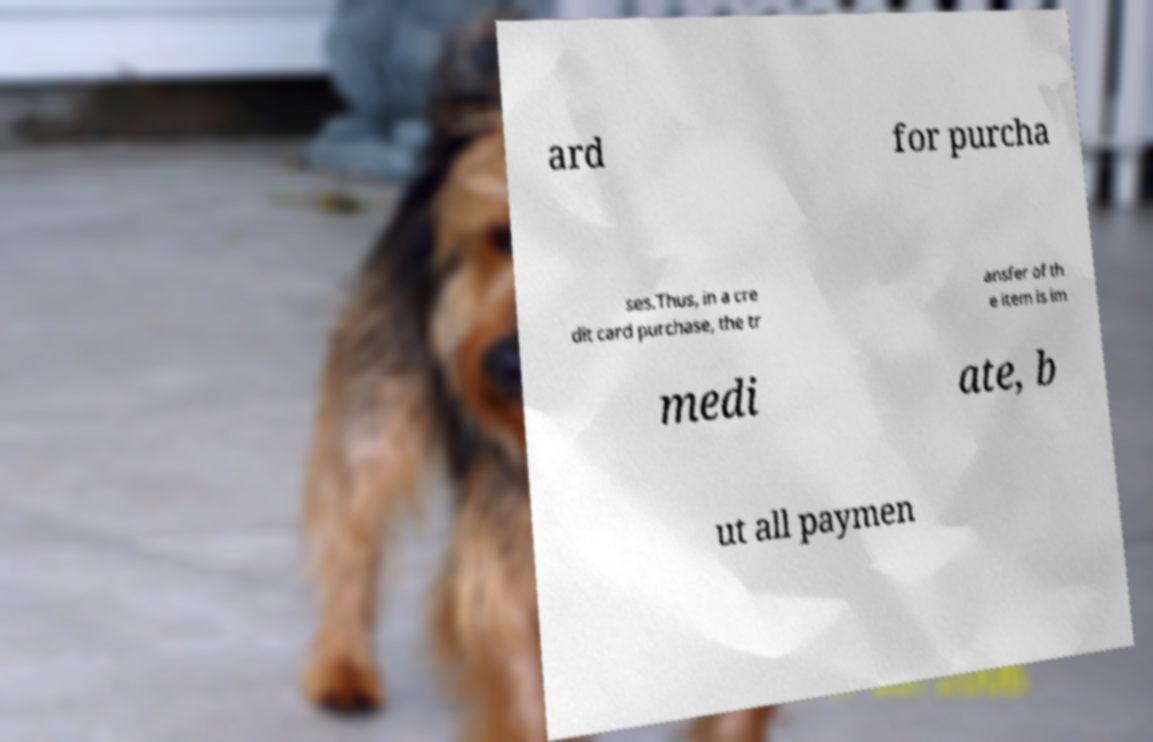For documentation purposes, I need the text within this image transcribed. Could you provide that? ard for purcha ses.Thus, in a cre dit card purchase, the tr ansfer of th e item is im medi ate, b ut all paymen 